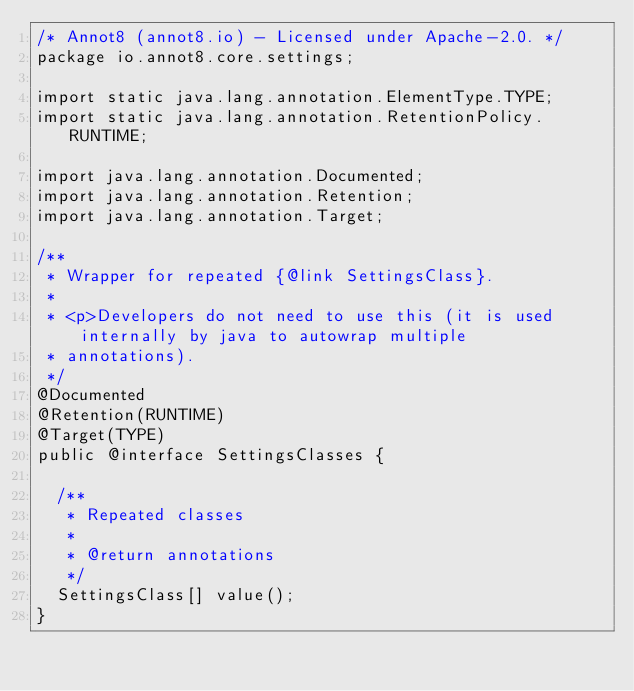<code> <loc_0><loc_0><loc_500><loc_500><_Java_>/* Annot8 (annot8.io) - Licensed under Apache-2.0. */
package io.annot8.core.settings;

import static java.lang.annotation.ElementType.TYPE;
import static java.lang.annotation.RetentionPolicy.RUNTIME;

import java.lang.annotation.Documented;
import java.lang.annotation.Retention;
import java.lang.annotation.Target;

/**
 * Wrapper for repeated {@link SettingsClass}.
 *
 * <p>Developers do not need to use this (it is used internally by java to autowrap multiple
 * annotations).
 */
@Documented
@Retention(RUNTIME)
@Target(TYPE)
public @interface SettingsClasses {

  /**
   * Repeated classes
   *
   * @return annotations
   */
  SettingsClass[] value();
}
</code> 